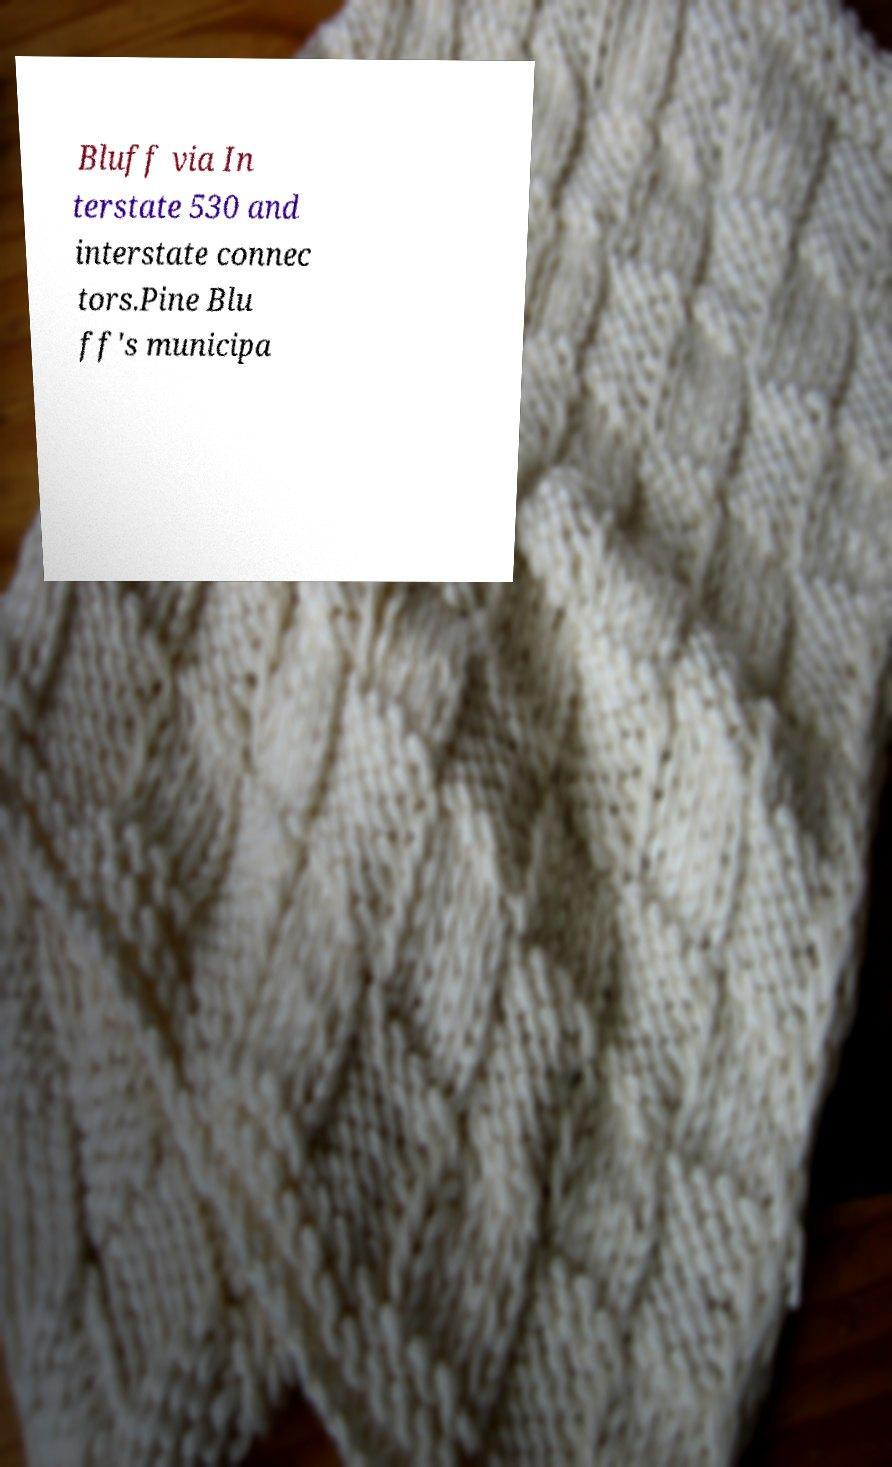What messages or text are displayed in this image? I need them in a readable, typed format. Bluff via In terstate 530 and interstate connec tors.Pine Blu ff's municipa 